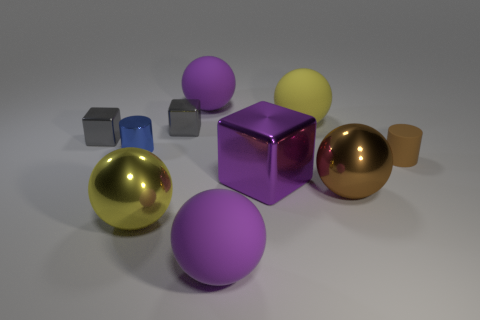What number of yellow shiny cubes are there?
Provide a succinct answer. 0. Do the yellow sphere that is in front of the blue cylinder and the large purple cube have the same material?
Provide a short and direct response. Yes. How many tiny cylinders are behind the yellow thing left of the purple matte ball that is in front of the big purple metal block?
Provide a short and direct response. 2. What size is the brown cylinder?
Give a very brief answer. Small. What is the size of the gray metallic thing that is on the left side of the blue metallic cylinder?
Keep it short and to the point. Small. Do the rubber ball in front of the yellow rubber thing and the tiny metallic thing that is right of the metal cylinder have the same color?
Your answer should be very brief. No. What number of other things are the same shape as the large brown object?
Offer a terse response. 4. Are there an equal number of cylinders that are to the left of the small blue thing and small brown objects that are behind the large yellow rubber sphere?
Your response must be concise. Yes. Is the object that is in front of the yellow shiny thing made of the same material as the small cylinder left of the big brown metal sphere?
Your response must be concise. No. What number of other objects are the same size as the brown sphere?
Offer a very short reply. 5. 